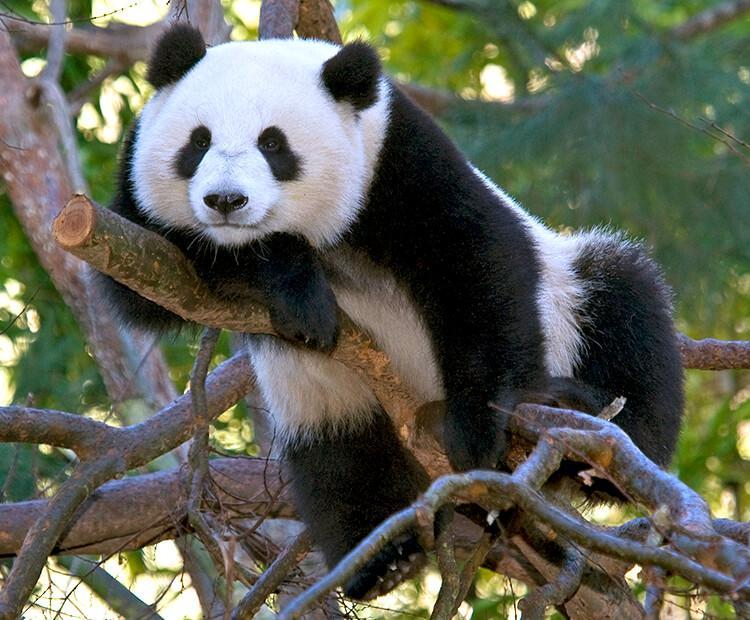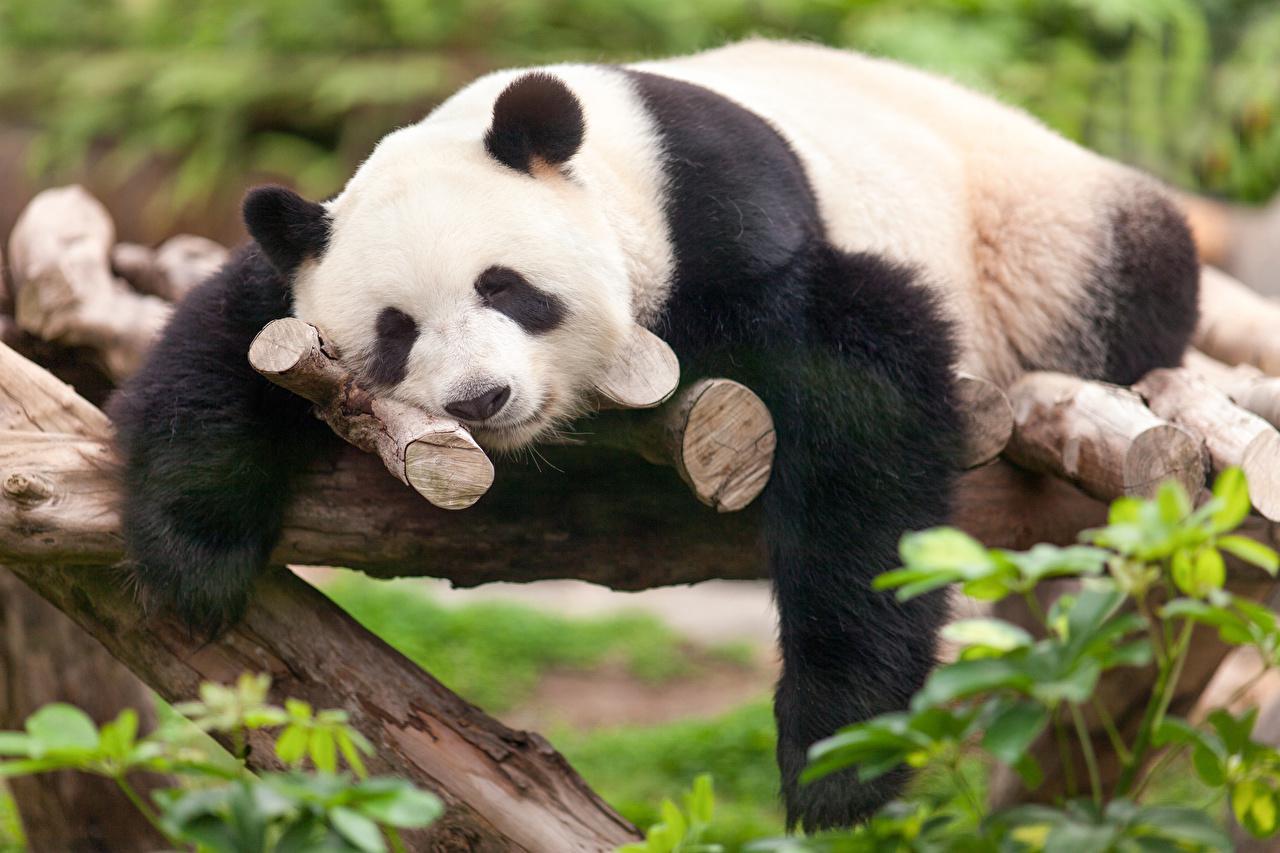The first image is the image on the left, the second image is the image on the right. For the images displayed, is the sentence "Two pandas are laying forward." factually correct? Answer yes or no. Yes. 